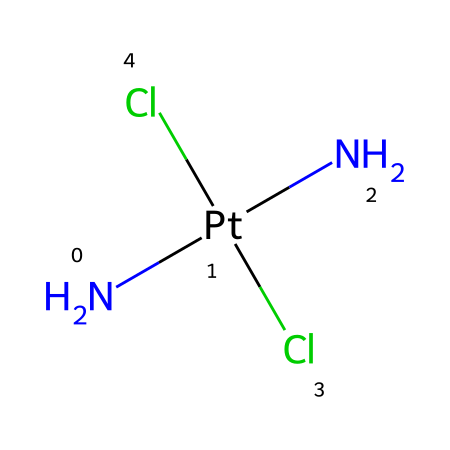What is the central metal in this compound? The central metal can be identified as the one represented by the element symbol "Pt" in the SMILES notation. It is the element around which the other ligands are coordinated.
Answer: platinum How many nitrogen atoms are present in this chemical structure? The SMILES notation indicates "N" appears twice, thus there are two nitrogen atoms in the structure.
Answer: two What type of chemical bonds are present between platinum and nitrogen? The connections between platinum and the nitrogen atoms are coordination bonds, which involve the donation of a pair of electrons from nitrogen to platinum.
Answer: coordination bonds What ligands are present in this platinum complex? The chemical has two different types of ligands indicated in the SMILES: nitrogen (N) and chloride (Cl), which bind to the platinum at its coordination sites.
Answer: nitrogen and chloride What is the oxidation state of platinum in this compound? To determine the oxidation state of platinum, we analyze the ligands; nitrogen typically has a -3 charge and each chloride has a -1 charge. The total charge must balance to be neutral; thus, platinum in this environment is +2.
Answer: +2 How many total chlorine atoms are part of this chemical structure? The chemical notation shows "Cl" appearing twice, indicating that there are two chlorine atoms in the molecule.
Answer: two 